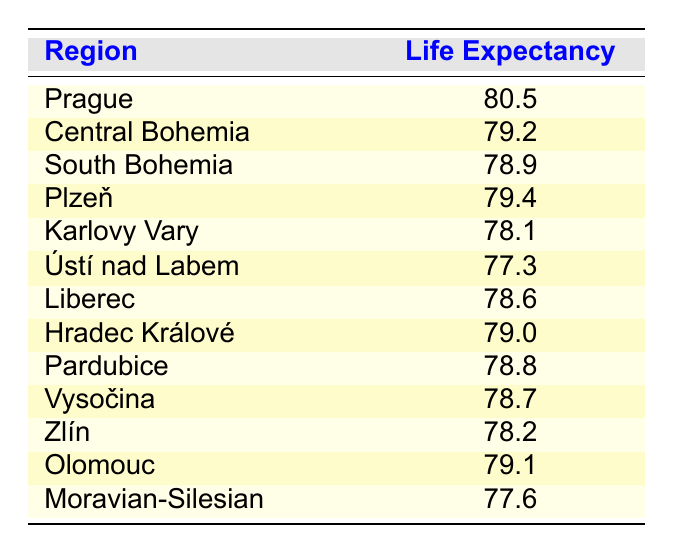What is the life expectancy in Prague? According to the table, the life expectancy in Prague is explicitly stated as 80.5 years.
Answer: 80.5 Which region has the highest life expectancy? The table shows that Prague has the highest life expectancy, which is 80.5 years, when comparing all regions listed.
Answer: Prague Is the life expectancy in South Bohemia higher than in Karlovy Vary? The life expectancy in South Bohemia is 78.9 years, while in Karlovy Vary it is 78.1 years. Since 78.9 is greater than 78.1, it means South Bohemia has a higher life expectancy.
Answer: Yes What is the average life expectancy across the regions listed? First, we sum the life expectancies: (80.5 + 79.2 + 78.9 + 79.4 + 78.1 + 77.3 + 78.6 + 79.0 + 78.8 + 78.7 + 78.2 + 79.1 + 77.6) = 1004.6. There are 13 regions, so the average is 1004.6 / 13 ≈ 77.27.
Answer: 77.27 Is it true that the life expectancy in Moravian-Silesian is less than 78 years? The respective life expectancy in Moravian-Silesian is indicated as 77.6 years, which is indeed less than 78, confirming the statement.
Answer: Yes Which regions have a life expectancy lower than 79 years? Looking at the table, the regions with life expectancy lower than 79 years are South Bohemia (78.9), Karlovy Vary (78.1), Ústí nad Labem (77.3), Liberec (78.6), Pardubice (78.8), Vysočina (78.7), Zlín (78.2), Olomouc (79.1), and Moravian-Silesian (77.6).
Answer: South Bohemia, Karlovy Vary, Ústí nad Labem, Liberec, Pardubice, Vysočina, Zlín, Moravian-Silesian Which region has a life expectancy that is exactly 78.8 years? The table indicates that Pardubice has a life expectancy recorded as 78.8 years, making it the specific region with that value.
Answer: Pardubice What is the difference in life expectancy between Prague and Ústí nad Labem? The life expectancy in Prague is 80.5 years, while that in Ústí nad Labem is 77.3 years. The difference is calculated as 80.5 - 77.3 = 3.2 years.
Answer: 3.2 Is life expectancy in the Central Bohemia higher than in Liberec? Central Bohemia has a life expectancy of 79.2 years, while Liberec has 78.6 years. Since 79.2 is greater than 78.6, Central Bohemia has a higher life expectancy.
Answer: Yes 